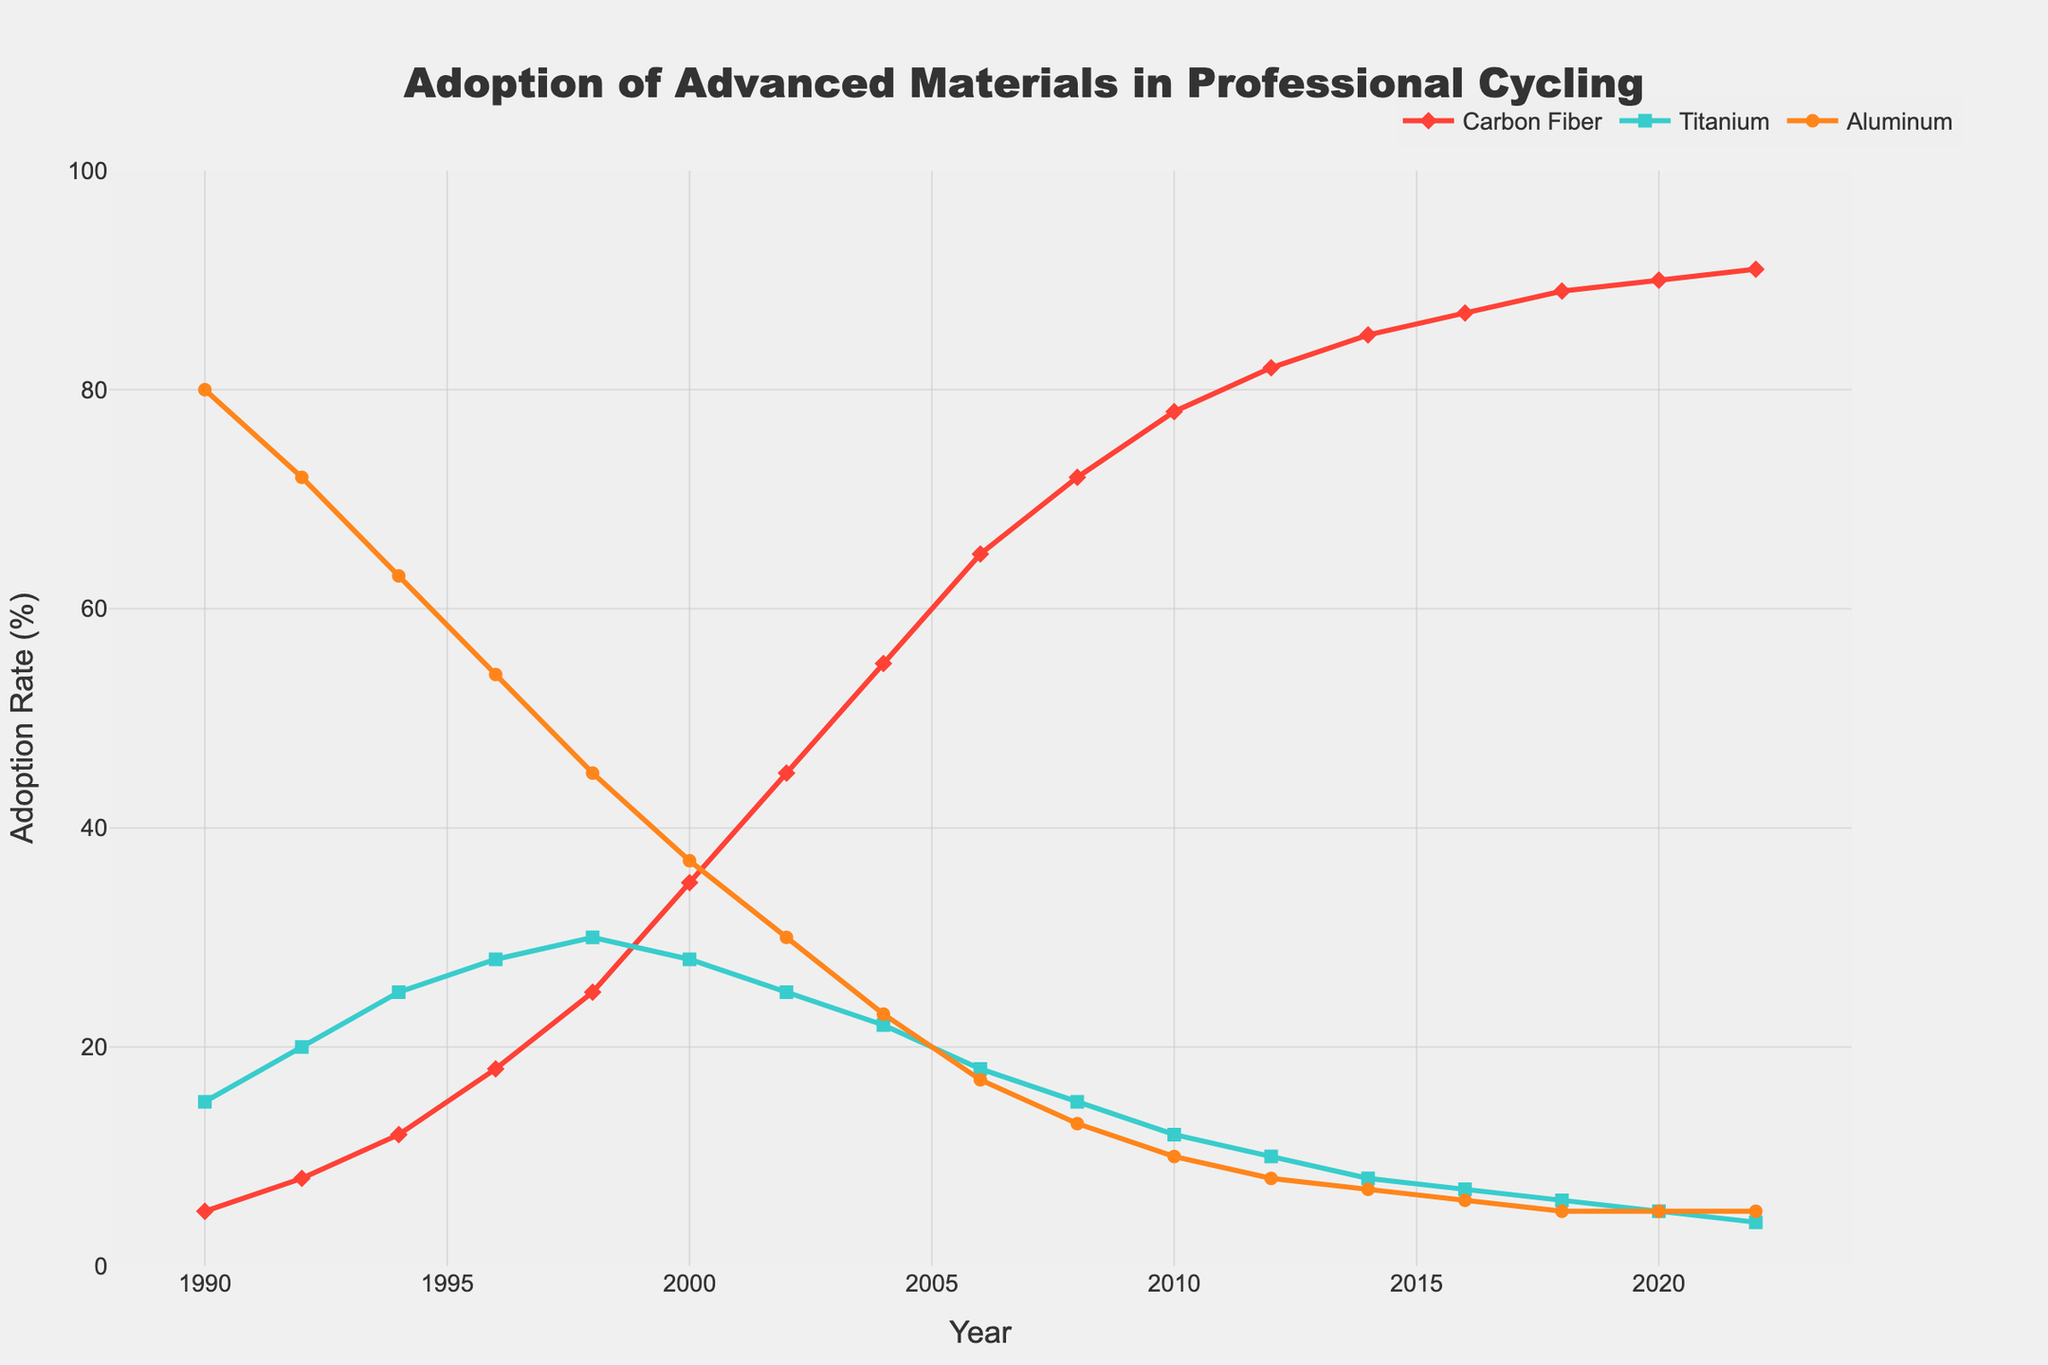What's the overall trend for the adoption rate of carbon fiber from 1990 to 2022? The adoption rate of carbon fiber steadily increases from 5% in 1990 to 91% in 2022, showing a clear upward trend.
Answer: Upward trend How does the adoption rate of titanium in 2022 compare to its adoption rate in 1998? In 1998, the adoption rate of titanium was 30%, while in 2022 it had decreased to 4%, indicating a significant drop.
Answer: Decreased Which material had the highest adoption rate in 1990? In 1990, aluminum had the highest adoption rate at 80%, compared to carbon fiber at 5% and titanium at 15%.
Answer: Aluminum By what percentage did the adoption of carbon fiber increase from 1990 to 2000? The adoption of carbon fiber increased from 5% in 1990 to 35% in 2000. The increase is 35% - 5% = 30%.
Answer: 30% Between what years did aluminum see the greatest decrease in adoption rate? The steepest decrease in aluminum's adoption rate occurred between 1996 (54%) and 1998 (45%), a drop of 9 percentage points.
Answer: 1996 to 1998 Which material had the most consistent adoption rate decrease over the years? Aluminum had the most consistent decrease in adoption rate, steadily declining from 80% in 1990 to 5% in 2022.
Answer: Aluminum What was the adoption rate of carbon fiber when titanium first began to decrease? Titanium's adoption rate began to decrease around 2000. At that time, the adoption rate of carbon fiber was 35%.
Answer: 35% How has the adoption rate of titanium changed from 2000 to 2022? The adoption rate of titanium decreased from 28% in 2000 to 4% in 2022.
Answer: Decreased When did carbon fiber surpass titanium in adoption rate? Carbon fiber surpassed titanium in adoption rate around 1998, when carbon fiber was at 25% and titanium was at 30%, and by 2000, carbon fiber was at 35% and titanium was at 28%.
Answer: Around 1998 